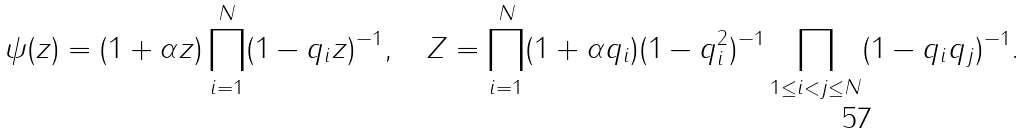<formula> <loc_0><loc_0><loc_500><loc_500>\psi ( z ) = ( 1 + \alpha z ) \prod _ { i = 1 } ^ { N } ( 1 - q _ { i } z ) ^ { - 1 } , \quad Z = \prod _ { i = 1 } ^ { N } ( 1 + \alpha q _ { i } ) ( 1 - q _ { i } ^ { 2 } ) ^ { - 1 } \prod _ { 1 \leq i < j \leq N } ( 1 - q _ { i } q _ { j } ) ^ { - 1 } .</formula> 